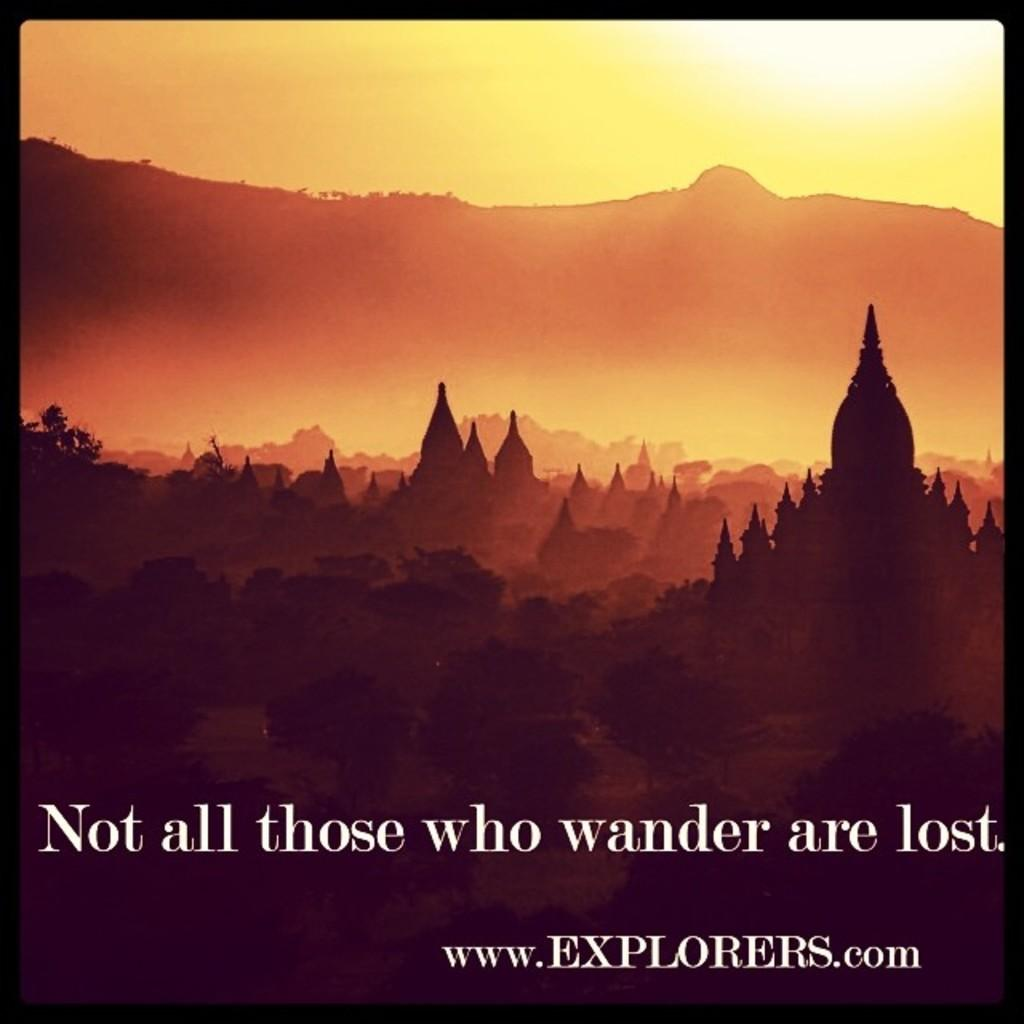<image>
Share a concise interpretation of the image provided. A poster that says Not All Those who Wonder Are Lost with a mountain and sunset in the background. 